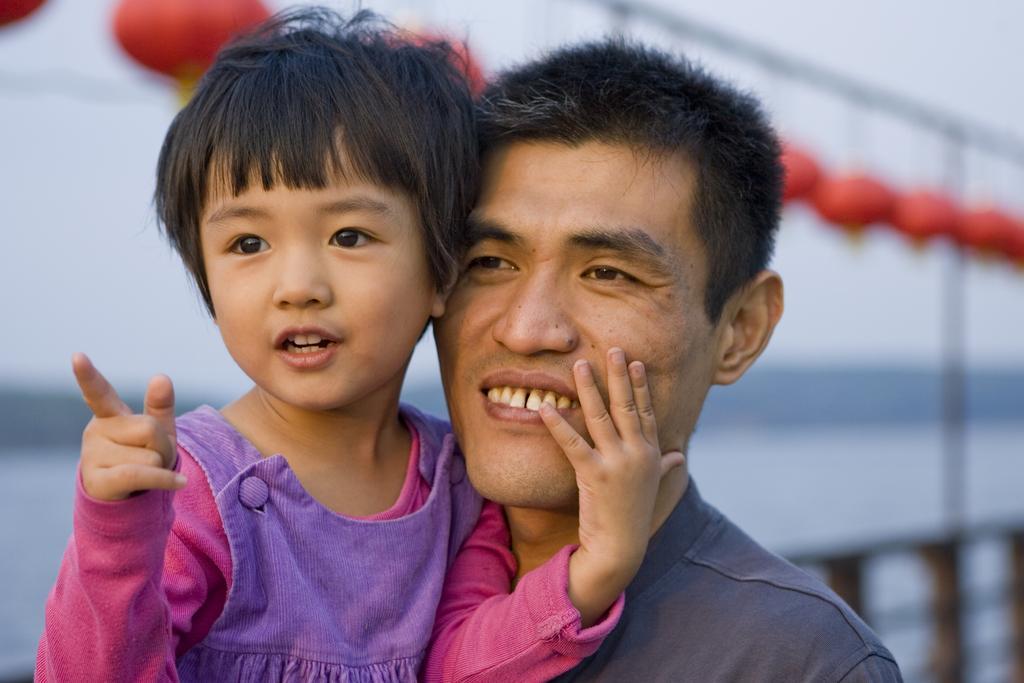Can you describe this image briefly? In the center of the image there is a man and a girl. At the bottom of the image we can see a bridge. In the background of the image we can see balloons, poles, water. 